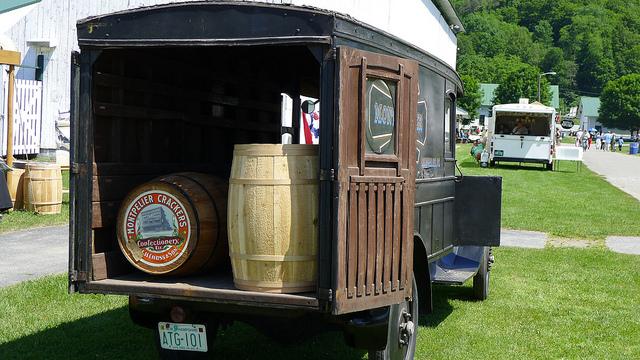What is the license plate number of the vehicle with two barrels in the back of the truck?
Be succinct. At-101. Is the truck parked in the grass?
Be succinct. Yes. What color is the barrel on the back of the truck?
Concise answer only. Tan. 